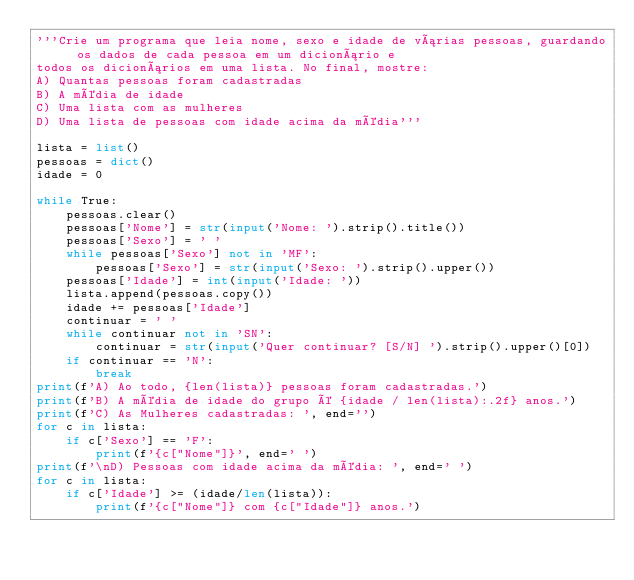Convert code to text. <code><loc_0><loc_0><loc_500><loc_500><_Python_>'''Crie um programa que leia nome, sexo e idade de várias pessoas, guardando os dados de cada pessoa em um dicionário e
todos os dicionários em uma lista. No final, mostre:
A) Quantas pessoas foram cadastradas
B) A média de idade
C) Uma lista com as mulheres
D) Uma lista de pessoas com idade acima da média'''

lista = list()
pessoas = dict()
idade = 0

while True:
    pessoas.clear()
    pessoas['Nome'] = str(input('Nome: ').strip().title())
    pessoas['Sexo'] = ' '
    while pessoas['Sexo'] not in 'MF':
        pessoas['Sexo'] = str(input('Sexo: ').strip().upper())
    pessoas['Idade'] = int(input('Idade: '))
    lista.append(pessoas.copy())
    idade += pessoas['Idade']
    continuar = ' '
    while continuar not in 'SN':
        continuar = str(input('Quer continuar? [S/N] ').strip().upper()[0])
    if continuar == 'N':
        break
print(f'A) Ao todo, {len(lista)} pessoas foram cadastradas.')
print(f'B) A média de idade do grupo é {idade / len(lista):.2f} anos.')
print(f'C) As Mulheres cadastradas: ', end='')
for c in lista:
    if c['Sexo'] == 'F':
        print(f'{c["Nome"]}', end=' ')
print(f'\nD) Pessoas com idade acima da média: ', end=' ')
for c in lista:
    if c['Idade'] >= (idade/len(lista)):
        print(f'{c["Nome"]} com {c["Idade"]} anos.')



</code> 